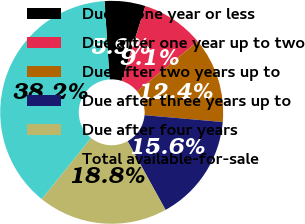<chart> <loc_0><loc_0><loc_500><loc_500><pie_chart><fcel>Due in one year or less<fcel>Due after one year up to two<fcel>Due after two years up to<fcel>Due after three years up to<fcel>Due after four years<fcel>Total available-for-sale<nl><fcel>5.91%<fcel>9.14%<fcel>12.36%<fcel>15.59%<fcel>18.82%<fcel>38.18%<nl></chart> 